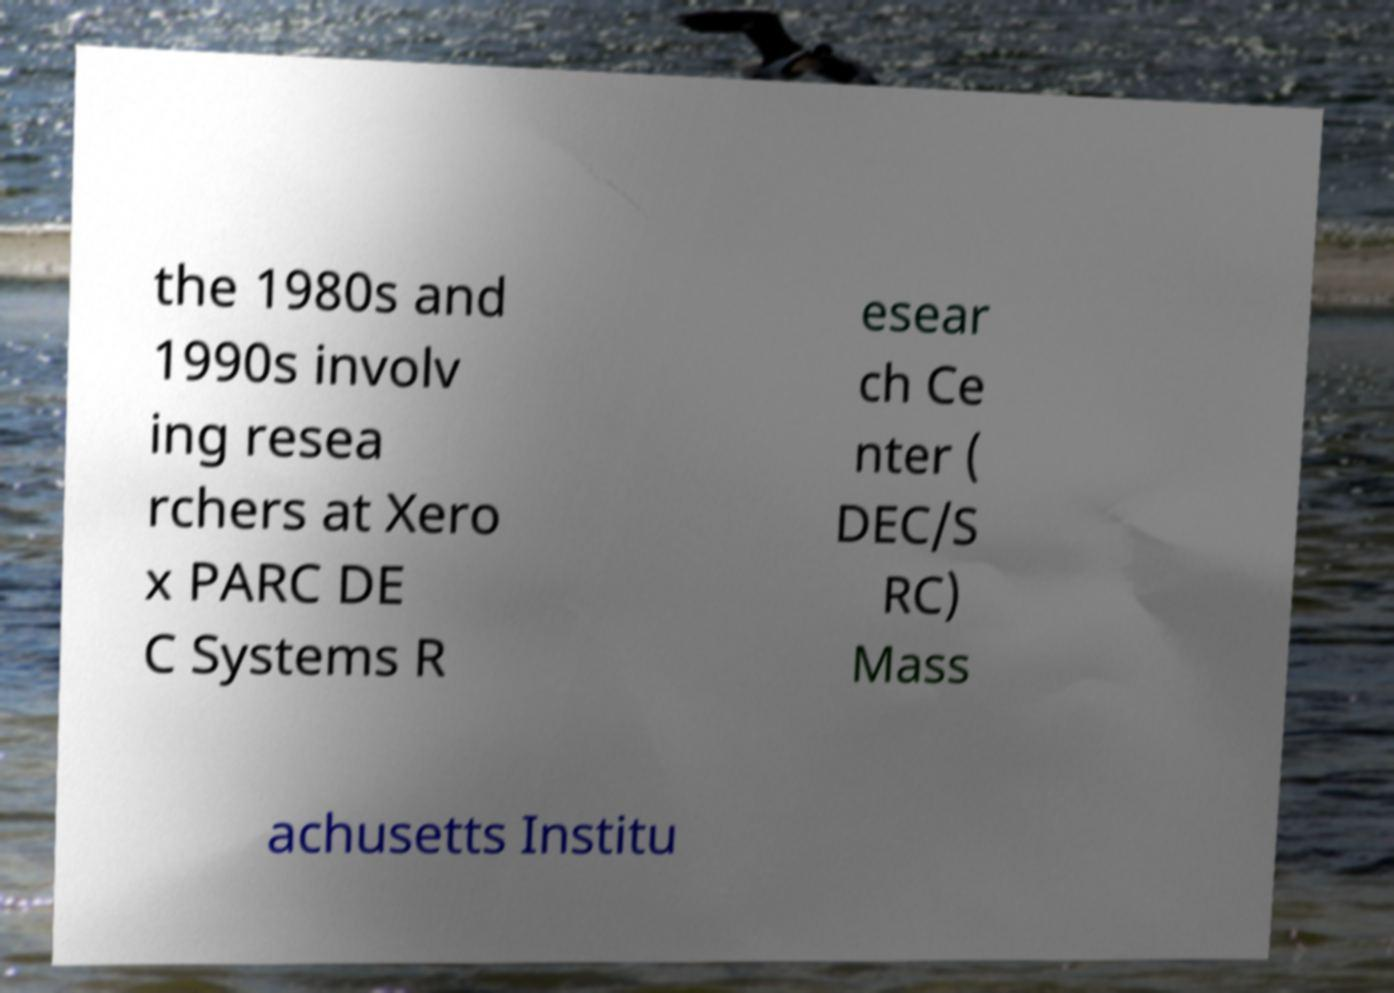Could you assist in decoding the text presented in this image and type it out clearly? the 1980s and 1990s involv ing resea rchers at Xero x PARC DE C Systems R esear ch Ce nter ( DEC/S RC) Mass achusetts Institu 